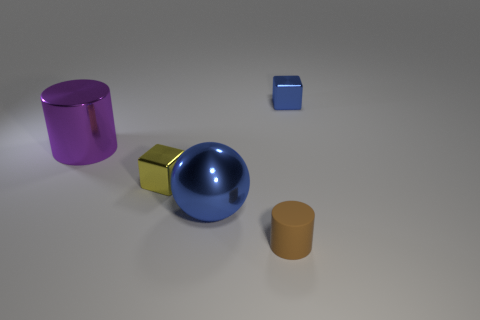Could the shadows tell us the position of the light source? Yes, by analyzing the direction of the shadows cast by the objects in the image, one can infer that the light source is positioned off to the right-hand side of the frame, likely at an elevated angle given how the shadows are elongated across the surface away from the objects. 